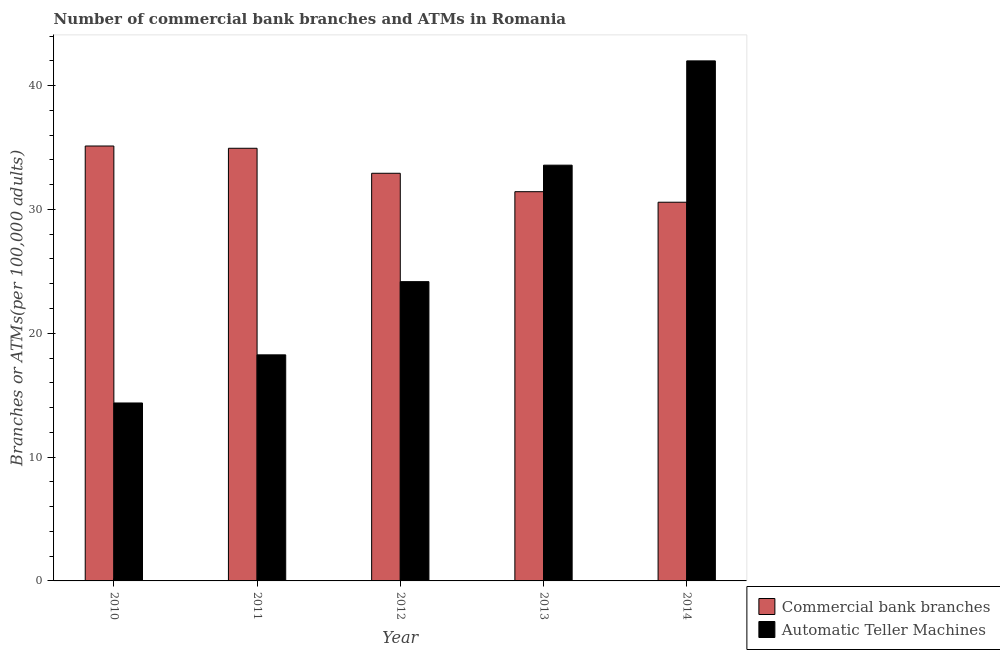How many different coloured bars are there?
Offer a terse response. 2. How many groups of bars are there?
Make the answer very short. 5. How many bars are there on the 2nd tick from the left?
Give a very brief answer. 2. What is the label of the 4th group of bars from the left?
Offer a terse response. 2013. In how many cases, is the number of bars for a given year not equal to the number of legend labels?
Offer a terse response. 0. What is the number of atms in 2011?
Make the answer very short. 18.26. Across all years, what is the maximum number of commercal bank branches?
Ensure brevity in your answer.  35.12. Across all years, what is the minimum number of atms?
Offer a terse response. 14.37. In which year was the number of commercal bank branches maximum?
Give a very brief answer. 2010. What is the total number of atms in the graph?
Give a very brief answer. 132.36. What is the difference between the number of atms in 2011 and that in 2014?
Keep it short and to the point. -23.74. What is the difference between the number of atms in 2012 and the number of commercal bank branches in 2010?
Your answer should be compact. 9.8. What is the average number of commercal bank branches per year?
Your answer should be very brief. 33. What is the ratio of the number of commercal bank branches in 2010 to that in 2012?
Provide a short and direct response. 1.07. Is the number of commercal bank branches in 2010 less than that in 2011?
Provide a succinct answer. No. Is the difference between the number of commercal bank branches in 2011 and 2012 greater than the difference between the number of atms in 2011 and 2012?
Give a very brief answer. No. What is the difference between the highest and the second highest number of commercal bank branches?
Provide a short and direct response. 0.18. What is the difference between the highest and the lowest number of atms?
Offer a very short reply. 27.63. In how many years, is the number of atms greater than the average number of atms taken over all years?
Your answer should be very brief. 2. What does the 2nd bar from the left in 2011 represents?
Keep it short and to the point. Automatic Teller Machines. What does the 2nd bar from the right in 2012 represents?
Keep it short and to the point. Commercial bank branches. How many bars are there?
Your answer should be compact. 10. Does the graph contain any zero values?
Offer a terse response. No. How many legend labels are there?
Offer a terse response. 2. How are the legend labels stacked?
Your answer should be compact. Vertical. What is the title of the graph?
Give a very brief answer. Number of commercial bank branches and ATMs in Romania. Does "Age 65(male)" appear as one of the legend labels in the graph?
Give a very brief answer. No. What is the label or title of the X-axis?
Ensure brevity in your answer.  Year. What is the label or title of the Y-axis?
Your answer should be very brief. Branches or ATMs(per 100,0 adults). What is the Branches or ATMs(per 100,000 adults) of Commercial bank branches in 2010?
Keep it short and to the point. 35.12. What is the Branches or ATMs(per 100,000 adults) in Automatic Teller Machines in 2010?
Offer a very short reply. 14.37. What is the Branches or ATMs(per 100,000 adults) of Commercial bank branches in 2011?
Your response must be concise. 34.94. What is the Branches or ATMs(per 100,000 adults) of Automatic Teller Machines in 2011?
Keep it short and to the point. 18.26. What is the Branches or ATMs(per 100,000 adults) of Commercial bank branches in 2012?
Provide a succinct answer. 32.92. What is the Branches or ATMs(per 100,000 adults) in Automatic Teller Machines in 2012?
Your answer should be compact. 24.17. What is the Branches or ATMs(per 100,000 adults) of Commercial bank branches in 2013?
Provide a succinct answer. 31.43. What is the Branches or ATMs(per 100,000 adults) of Automatic Teller Machines in 2013?
Ensure brevity in your answer.  33.57. What is the Branches or ATMs(per 100,000 adults) of Commercial bank branches in 2014?
Your answer should be very brief. 30.58. What is the Branches or ATMs(per 100,000 adults) in Automatic Teller Machines in 2014?
Offer a very short reply. 41.99. Across all years, what is the maximum Branches or ATMs(per 100,000 adults) of Commercial bank branches?
Provide a short and direct response. 35.12. Across all years, what is the maximum Branches or ATMs(per 100,000 adults) in Automatic Teller Machines?
Ensure brevity in your answer.  41.99. Across all years, what is the minimum Branches or ATMs(per 100,000 adults) of Commercial bank branches?
Offer a terse response. 30.58. Across all years, what is the minimum Branches or ATMs(per 100,000 adults) in Automatic Teller Machines?
Offer a very short reply. 14.37. What is the total Branches or ATMs(per 100,000 adults) of Commercial bank branches in the graph?
Make the answer very short. 164.99. What is the total Branches or ATMs(per 100,000 adults) in Automatic Teller Machines in the graph?
Keep it short and to the point. 132.36. What is the difference between the Branches or ATMs(per 100,000 adults) of Commercial bank branches in 2010 and that in 2011?
Make the answer very short. 0.18. What is the difference between the Branches or ATMs(per 100,000 adults) in Automatic Teller Machines in 2010 and that in 2011?
Provide a short and direct response. -3.89. What is the difference between the Branches or ATMs(per 100,000 adults) of Commercial bank branches in 2010 and that in 2012?
Ensure brevity in your answer.  2.2. What is the difference between the Branches or ATMs(per 100,000 adults) of Automatic Teller Machines in 2010 and that in 2012?
Your answer should be compact. -9.8. What is the difference between the Branches or ATMs(per 100,000 adults) of Commercial bank branches in 2010 and that in 2013?
Give a very brief answer. 3.69. What is the difference between the Branches or ATMs(per 100,000 adults) in Automatic Teller Machines in 2010 and that in 2013?
Your answer should be very brief. -19.2. What is the difference between the Branches or ATMs(per 100,000 adults) of Commercial bank branches in 2010 and that in 2014?
Your answer should be very brief. 4.54. What is the difference between the Branches or ATMs(per 100,000 adults) of Automatic Teller Machines in 2010 and that in 2014?
Your answer should be compact. -27.63. What is the difference between the Branches or ATMs(per 100,000 adults) of Commercial bank branches in 2011 and that in 2012?
Ensure brevity in your answer.  2.02. What is the difference between the Branches or ATMs(per 100,000 adults) of Automatic Teller Machines in 2011 and that in 2012?
Provide a succinct answer. -5.91. What is the difference between the Branches or ATMs(per 100,000 adults) of Commercial bank branches in 2011 and that in 2013?
Your answer should be very brief. 3.51. What is the difference between the Branches or ATMs(per 100,000 adults) in Automatic Teller Machines in 2011 and that in 2013?
Offer a terse response. -15.32. What is the difference between the Branches or ATMs(per 100,000 adults) in Commercial bank branches in 2011 and that in 2014?
Your response must be concise. 4.36. What is the difference between the Branches or ATMs(per 100,000 adults) of Automatic Teller Machines in 2011 and that in 2014?
Offer a very short reply. -23.74. What is the difference between the Branches or ATMs(per 100,000 adults) in Commercial bank branches in 2012 and that in 2013?
Your answer should be compact. 1.49. What is the difference between the Branches or ATMs(per 100,000 adults) in Automatic Teller Machines in 2012 and that in 2013?
Your answer should be very brief. -9.41. What is the difference between the Branches or ATMs(per 100,000 adults) of Commercial bank branches in 2012 and that in 2014?
Provide a short and direct response. 2.34. What is the difference between the Branches or ATMs(per 100,000 adults) in Automatic Teller Machines in 2012 and that in 2014?
Your answer should be very brief. -17.83. What is the difference between the Branches or ATMs(per 100,000 adults) in Commercial bank branches in 2013 and that in 2014?
Give a very brief answer. 0.85. What is the difference between the Branches or ATMs(per 100,000 adults) of Automatic Teller Machines in 2013 and that in 2014?
Your response must be concise. -8.42. What is the difference between the Branches or ATMs(per 100,000 adults) of Commercial bank branches in 2010 and the Branches or ATMs(per 100,000 adults) of Automatic Teller Machines in 2011?
Keep it short and to the point. 16.86. What is the difference between the Branches or ATMs(per 100,000 adults) of Commercial bank branches in 2010 and the Branches or ATMs(per 100,000 adults) of Automatic Teller Machines in 2012?
Offer a very short reply. 10.95. What is the difference between the Branches or ATMs(per 100,000 adults) in Commercial bank branches in 2010 and the Branches or ATMs(per 100,000 adults) in Automatic Teller Machines in 2013?
Offer a terse response. 1.55. What is the difference between the Branches or ATMs(per 100,000 adults) of Commercial bank branches in 2010 and the Branches or ATMs(per 100,000 adults) of Automatic Teller Machines in 2014?
Ensure brevity in your answer.  -6.88. What is the difference between the Branches or ATMs(per 100,000 adults) in Commercial bank branches in 2011 and the Branches or ATMs(per 100,000 adults) in Automatic Teller Machines in 2012?
Give a very brief answer. 10.77. What is the difference between the Branches or ATMs(per 100,000 adults) in Commercial bank branches in 2011 and the Branches or ATMs(per 100,000 adults) in Automatic Teller Machines in 2013?
Provide a succinct answer. 1.36. What is the difference between the Branches or ATMs(per 100,000 adults) in Commercial bank branches in 2011 and the Branches or ATMs(per 100,000 adults) in Automatic Teller Machines in 2014?
Offer a terse response. -7.06. What is the difference between the Branches or ATMs(per 100,000 adults) in Commercial bank branches in 2012 and the Branches or ATMs(per 100,000 adults) in Automatic Teller Machines in 2013?
Make the answer very short. -0.65. What is the difference between the Branches or ATMs(per 100,000 adults) in Commercial bank branches in 2012 and the Branches or ATMs(per 100,000 adults) in Automatic Teller Machines in 2014?
Offer a very short reply. -9.08. What is the difference between the Branches or ATMs(per 100,000 adults) of Commercial bank branches in 2013 and the Branches or ATMs(per 100,000 adults) of Automatic Teller Machines in 2014?
Your answer should be compact. -10.56. What is the average Branches or ATMs(per 100,000 adults) in Commercial bank branches per year?
Offer a very short reply. 33. What is the average Branches or ATMs(per 100,000 adults) in Automatic Teller Machines per year?
Provide a succinct answer. 26.47. In the year 2010, what is the difference between the Branches or ATMs(per 100,000 adults) in Commercial bank branches and Branches or ATMs(per 100,000 adults) in Automatic Teller Machines?
Offer a terse response. 20.75. In the year 2011, what is the difference between the Branches or ATMs(per 100,000 adults) of Commercial bank branches and Branches or ATMs(per 100,000 adults) of Automatic Teller Machines?
Your answer should be very brief. 16.68. In the year 2012, what is the difference between the Branches or ATMs(per 100,000 adults) in Commercial bank branches and Branches or ATMs(per 100,000 adults) in Automatic Teller Machines?
Make the answer very short. 8.75. In the year 2013, what is the difference between the Branches or ATMs(per 100,000 adults) in Commercial bank branches and Branches or ATMs(per 100,000 adults) in Automatic Teller Machines?
Your answer should be compact. -2.14. In the year 2014, what is the difference between the Branches or ATMs(per 100,000 adults) in Commercial bank branches and Branches or ATMs(per 100,000 adults) in Automatic Teller Machines?
Offer a very short reply. -11.41. What is the ratio of the Branches or ATMs(per 100,000 adults) of Commercial bank branches in 2010 to that in 2011?
Your response must be concise. 1.01. What is the ratio of the Branches or ATMs(per 100,000 adults) in Automatic Teller Machines in 2010 to that in 2011?
Your answer should be very brief. 0.79. What is the ratio of the Branches or ATMs(per 100,000 adults) of Commercial bank branches in 2010 to that in 2012?
Ensure brevity in your answer.  1.07. What is the ratio of the Branches or ATMs(per 100,000 adults) in Automatic Teller Machines in 2010 to that in 2012?
Your answer should be very brief. 0.59. What is the ratio of the Branches or ATMs(per 100,000 adults) in Commercial bank branches in 2010 to that in 2013?
Offer a terse response. 1.12. What is the ratio of the Branches or ATMs(per 100,000 adults) in Automatic Teller Machines in 2010 to that in 2013?
Ensure brevity in your answer.  0.43. What is the ratio of the Branches or ATMs(per 100,000 adults) in Commercial bank branches in 2010 to that in 2014?
Give a very brief answer. 1.15. What is the ratio of the Branches or ATMs(per 100,000 adults) of Automatic Teller Machines in 2010 to that in 2014?
Provide a succinct answer. 0.34. What is the ratio of the Branches or ATMs(per 100,000 adults) in Commercial bank branches in 2011 to that in 2012?
Offer a terse response. 1.06. What is the ratio of the Branches or ATMs(per 100,000 adults) of Automatic Teller Machines in 2011 to that in 2012?
Offer a terse response. 0.76. What is the ratio of the Branches or ATMs(per 100,000 adults) in Commercial bank branches in 2011 to that in 2013?
Your answer should be very brief. 1.11. What is the ratio of the Branches or ATMs(per 100,000 adults) of Automatic Teller Machines in 2011 to that in 2013?
Provide a short and direct response. 0.54. What is the ratio of the Branches or ATMs(per 100,000 adults) in Commercial bank branches in 2011 to that in 2014?
Provide a short and direct response. 1.14. What is the ratio of the Branches or ATMs(per 100,000 adults) of Automatic Teller Machines in 2011 to that in 2014?
Make the answer very short. 0.43. What is the ratio of the Branches or ATMs(per 100,000 adults) in Commercial bank branches in 2012 to that in 2013?
Keep it short and to the point. 1.05. What is the ratio of the Branches or ATMs(per 100,000 adults) in Automatic Teller Machines in 2012 to that in 2013?
Offer a very short reply. 0.72. What is the ratio of the Branches or ATMs(per 100,000 adults) in Commercial bank branches in 2012 to that in 2014?
Offer a terse response. 1.08. What is the ratio of the Branches or ATMs(per 100,000 adults) in Automatic Teller Machines in 2012 to that in 2014?
Your response must be concise. 0.58. What is the ratio of the Branches or ATMs(per 100,000 adults) of Commercial bank branches in 2013 to that in 2014?
Keep it short and to the point. 1.03. What is the ratio of the Branches or ATMs(per 100,000 adults) of Automatic Teller Machines in 2013 to that in 2014?
Give a very brief answer. 0.8. What is the difference between the highest and the second highest Branches or ATMs(per 100,000 adults) of Commercial bank branches?
Your answer should be very brief. 0.18. What is the difference between the highest and the second highest Branches or ATMs(per 100,000 adults) in Automatic Teller Machines?
Your answer should be compact. 8.42. What is the difference between the highest and the lowest Branches or ATMs(per 100,000 adults) in Commercial bank branches?
Give a very brief answer. 4.54. What is the difference between the highest and the lowest Branches or ATMs(per 100,000 adults) of Automatic Teller Machines?
Provide a short and direct response. 27.63. 